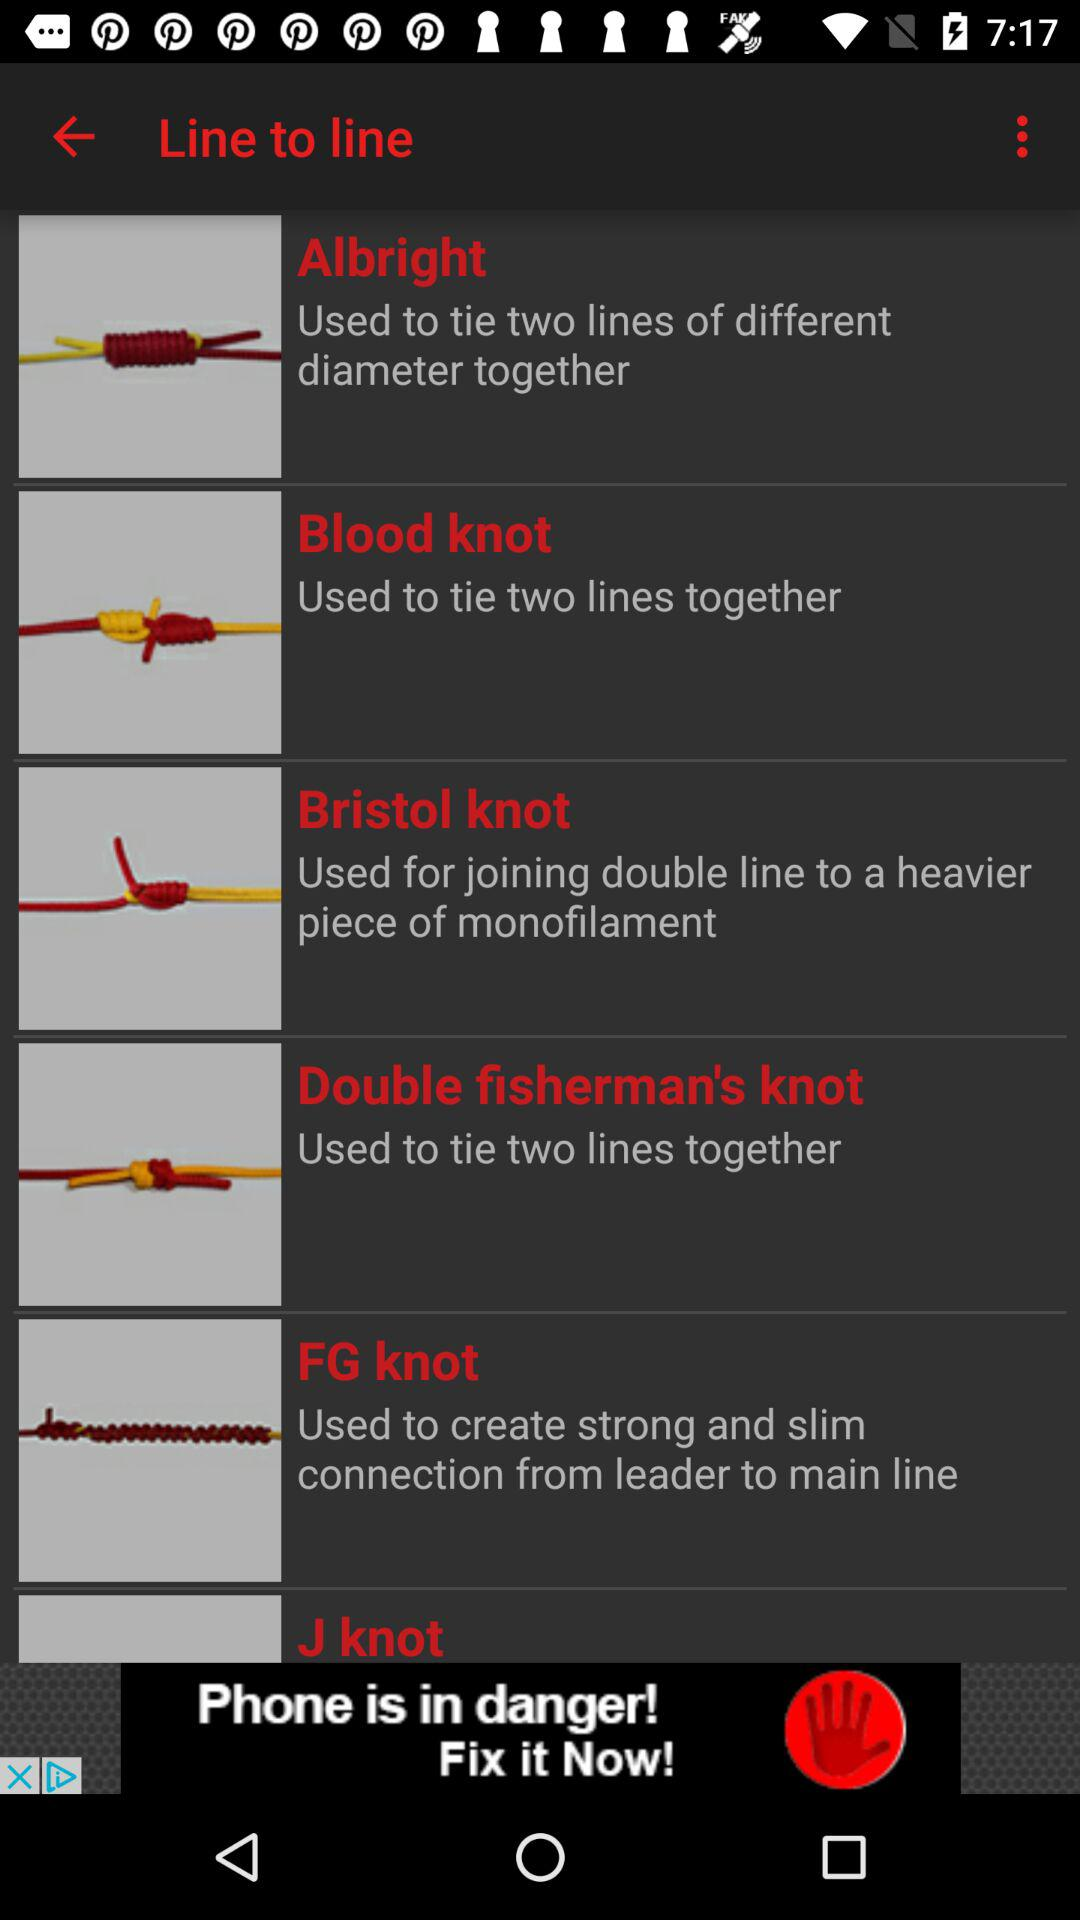What does "Blood knot" do? A "Blood knot" is used to tie two lines together. 